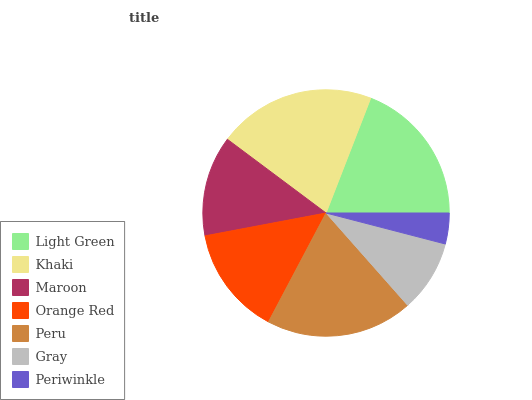Is Periwinkle the minimum?
Answer yes or no. Yes. Is Khaki the maximum?
Answer yes or no. Yes. Is Maroon the minimum?
Answer yes or no. No. Is Maroon the maximum?
Answer yes or no. No. Is Khaki greater than Maroon?
Answer yes or no. Yes. Is Maroon less than Khaki?
Answer yes or no. Yes. Is Maroon greater than Khaki?
Answer yes or no. No. Is Khaki less than Maroon?
Answer yes or no. No. Is Orange Red the high median?
Answer yes or no. Yes. Is Orange Red the low median?
Answer yes or no. Yes. Is Periwinkle the high median?
Answer yes or no. No. Is Khaki the low median?
Answer yes or no. No. 